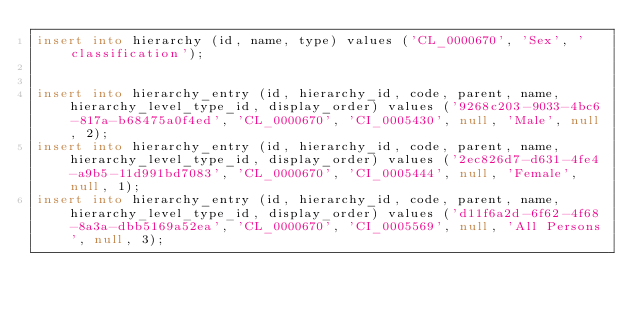Convert code to text. <code><loc_0><loc_0><loc_500><loc_500><_SQL_>insert into hierarchy (id, name, type) values ('CL_0000670', 'Sex', 'classification');


insert into hierarchy_entry (id, hierarchy_id, code, parent, name, hierarchy_level_type_id, display_order) values ('9268c203-9033-4bc6-817a-b68475a0f4ed', 'CL_0000670', 'CI_0005430', null, 'Male', null, 2);
insert into hierarchy_entry (id, hierarchy_id, code, parent, name, hierarchy_level_type_id, display_order) values ('2ec826d7-d631-4fe4-a9b5-11d991bd7083', 'CL_0000670', 'CI_0005444', null, 'Female', null, 1);
insert into hierarchy_entry (id, hierarchy_id, code, parent, name, hierarchy_level_type_id, display_order) values ('d11f6a2d-6f62-4f68-8a3a-dbb5169a52ea', 'CL_0000670', 'CI_0005569', null, 'All Persons', null, 3);
</code> 